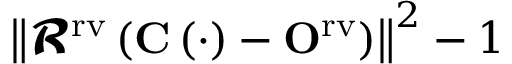<formula> <loc_0><loc_0><loc_500><loc_500>\left \| \mathbf c a l { R } ^ { r v } \left ( C \left ( \cdot \right ) - O ^ { r v } \right ) \right \| ^ { 2 } - 1</formula> 